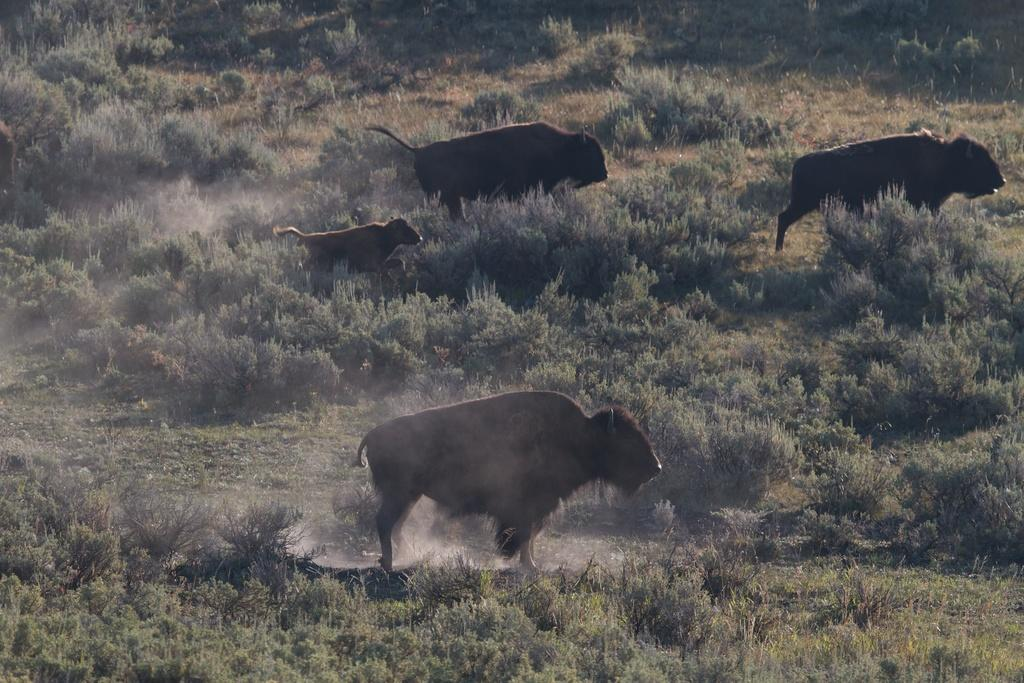What type of living organisms can be seen in the image? There are animals in the image. What are the animals doing in the image? The animals are walking on the grass. What type of vegetation is visible in the image? There are trees and plants in the image. How many horses are pushing the picture frame in the image? There are no horses or picture frames present in the image. 